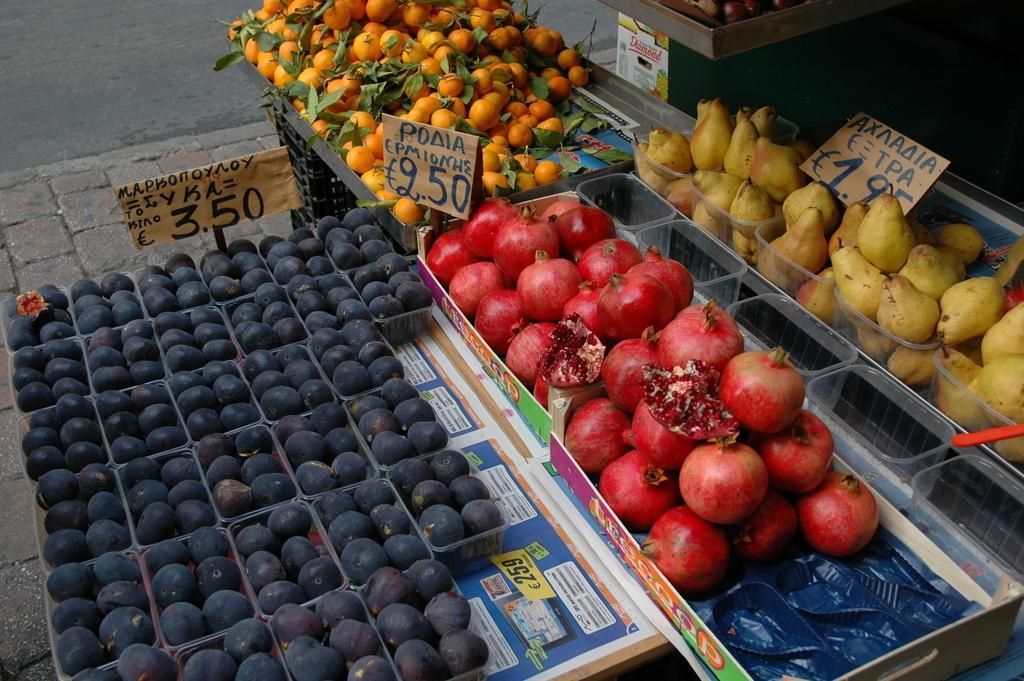Please provide a concise description of this image. In this image we can see there are a different types of fruits arranged in the baskets and placed on the table and there is a label with a price on it, in front of this there is a road. 